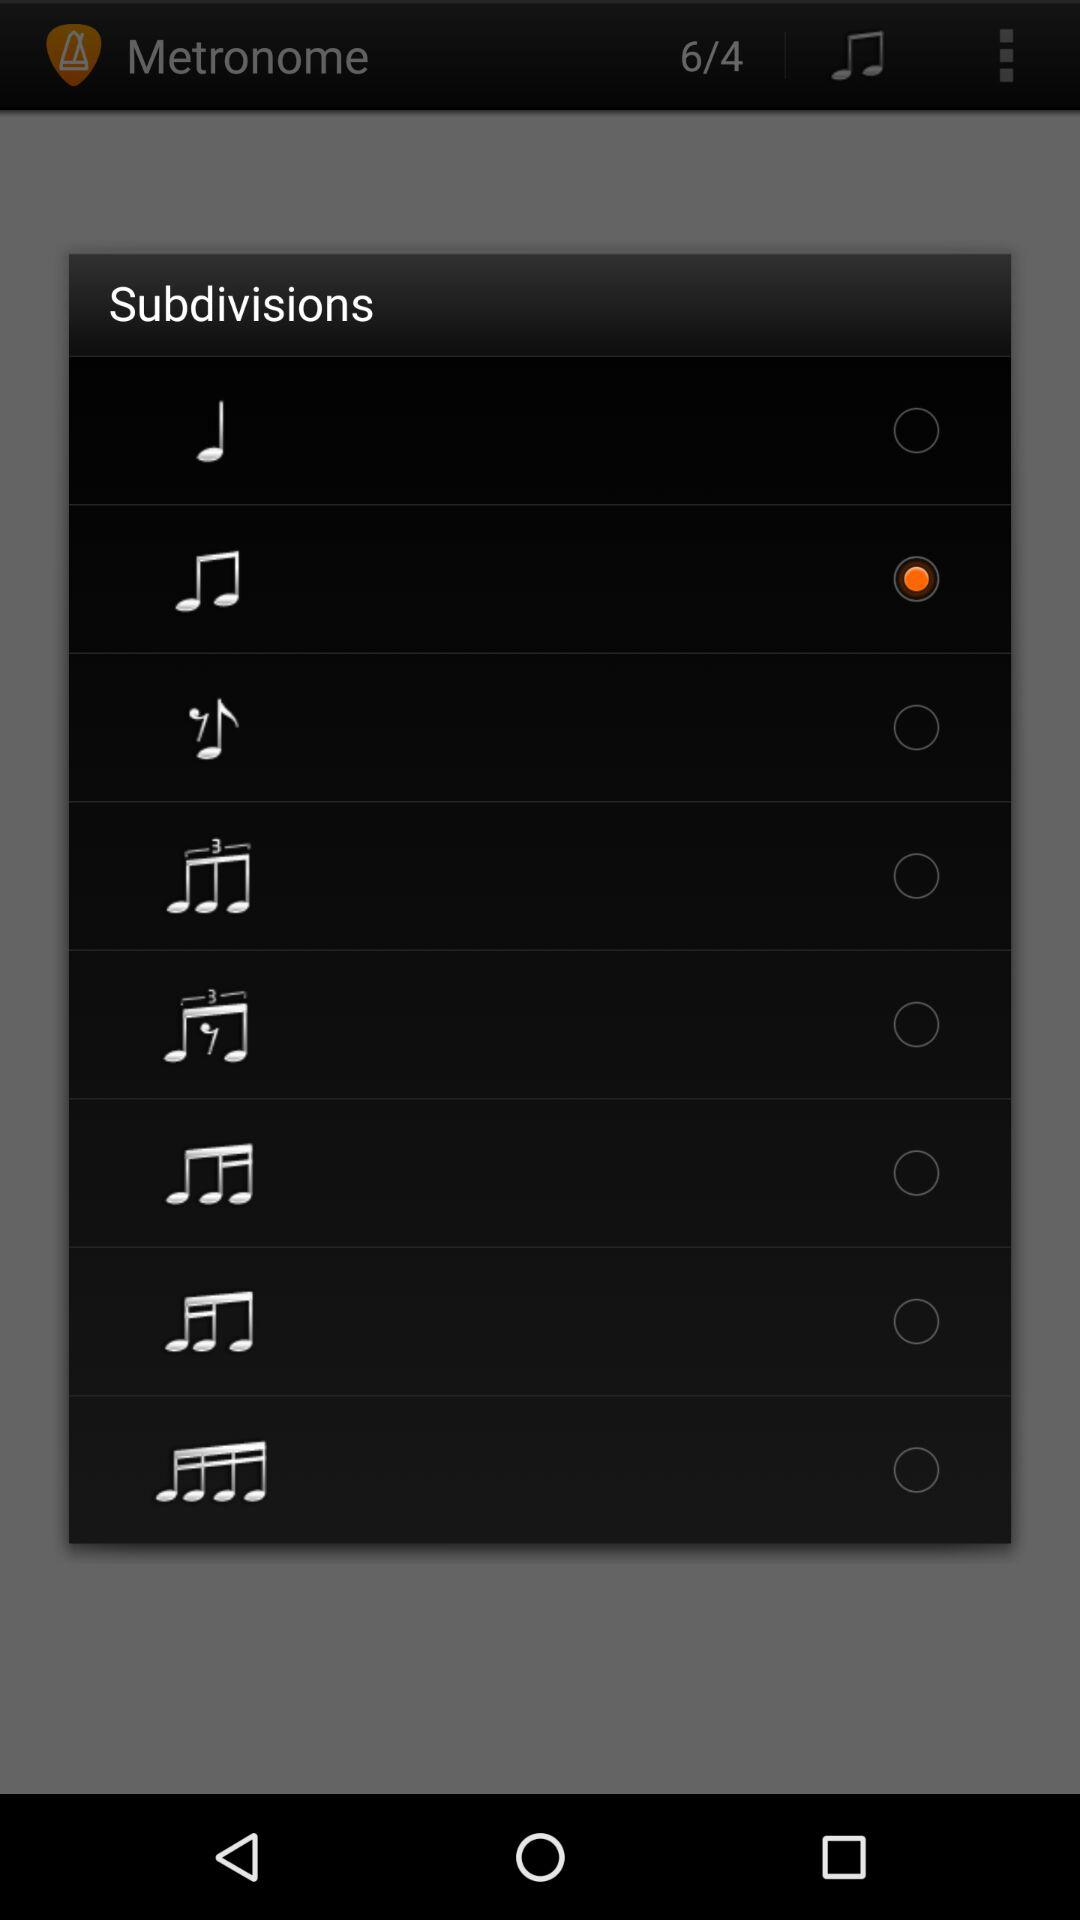How many subdivisions are there in total?
Answer the question using a single word or phrase. 8 